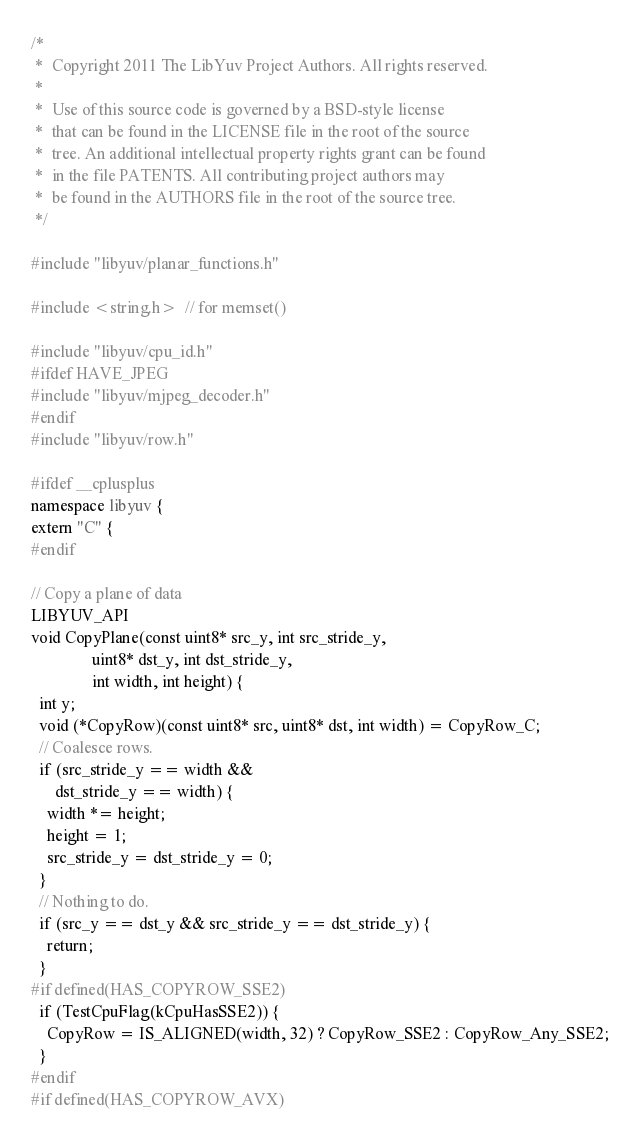Convert code to text. <code><loc_0><loc_0><loc_500><loc_500><_C++_>/*
 *  Copyright 2011 The LibYuv Project Authors. All rights reserved.
 *
 *  Use of this source code is governed by a BSD-style license
 *  that can be found in the LICENSE file in the root of the source
 *  tree. An additional intellectual property rights grant can be found
 *  in the file PATENTS. All contributing project authors may
 *  be found in the AUTHORS file in the root of the source tree.
 */

#include "libyuv/planar_functions.h"

#include <string.h>  // for memset()

#include "libyuv/cpu_id.h"
#ifdef HAVE_JPEG
#include "libyuv/mjpeg_decoder.h"
#endif
#include "libyuv/row.h"

#ifdef __cplusplus
namespace libyuv {
extern "C" {
#endif

// Copy a plane of data
LIBYUV_API
void CopyPlane(const uint8* src_y, int src_stride_y,
               uint8* dst_y, int dst_stride_y,
               int width, int height) {
  int y;
  void (*CopyRow)(const uint8* src, uint8* dst, int width) = CopyRow_C;
  // Coalesce rows.
  if (src_stride_y == width &&
      dst_stride_y == width) {
    width *= height;
    height = 1;
    src_stride_y = dst_stride_y = 0;
  }
  // Nothing to do.
  if (src_y == dst_y && src_stride_y == dst_stride_y) {
    return;
  }
#if defined(HAS_COPYROW_SSE2)
  if (TestCpuFlag(kCpuHasSSE2)) {
    CopyRow = IS_ALIGNED(width, 32) ? CopyRow_SSE2 : CopyRow_Any_SSE2;
  }
#endif
#if defined(HAS_COPYROW_AVX)</code> 